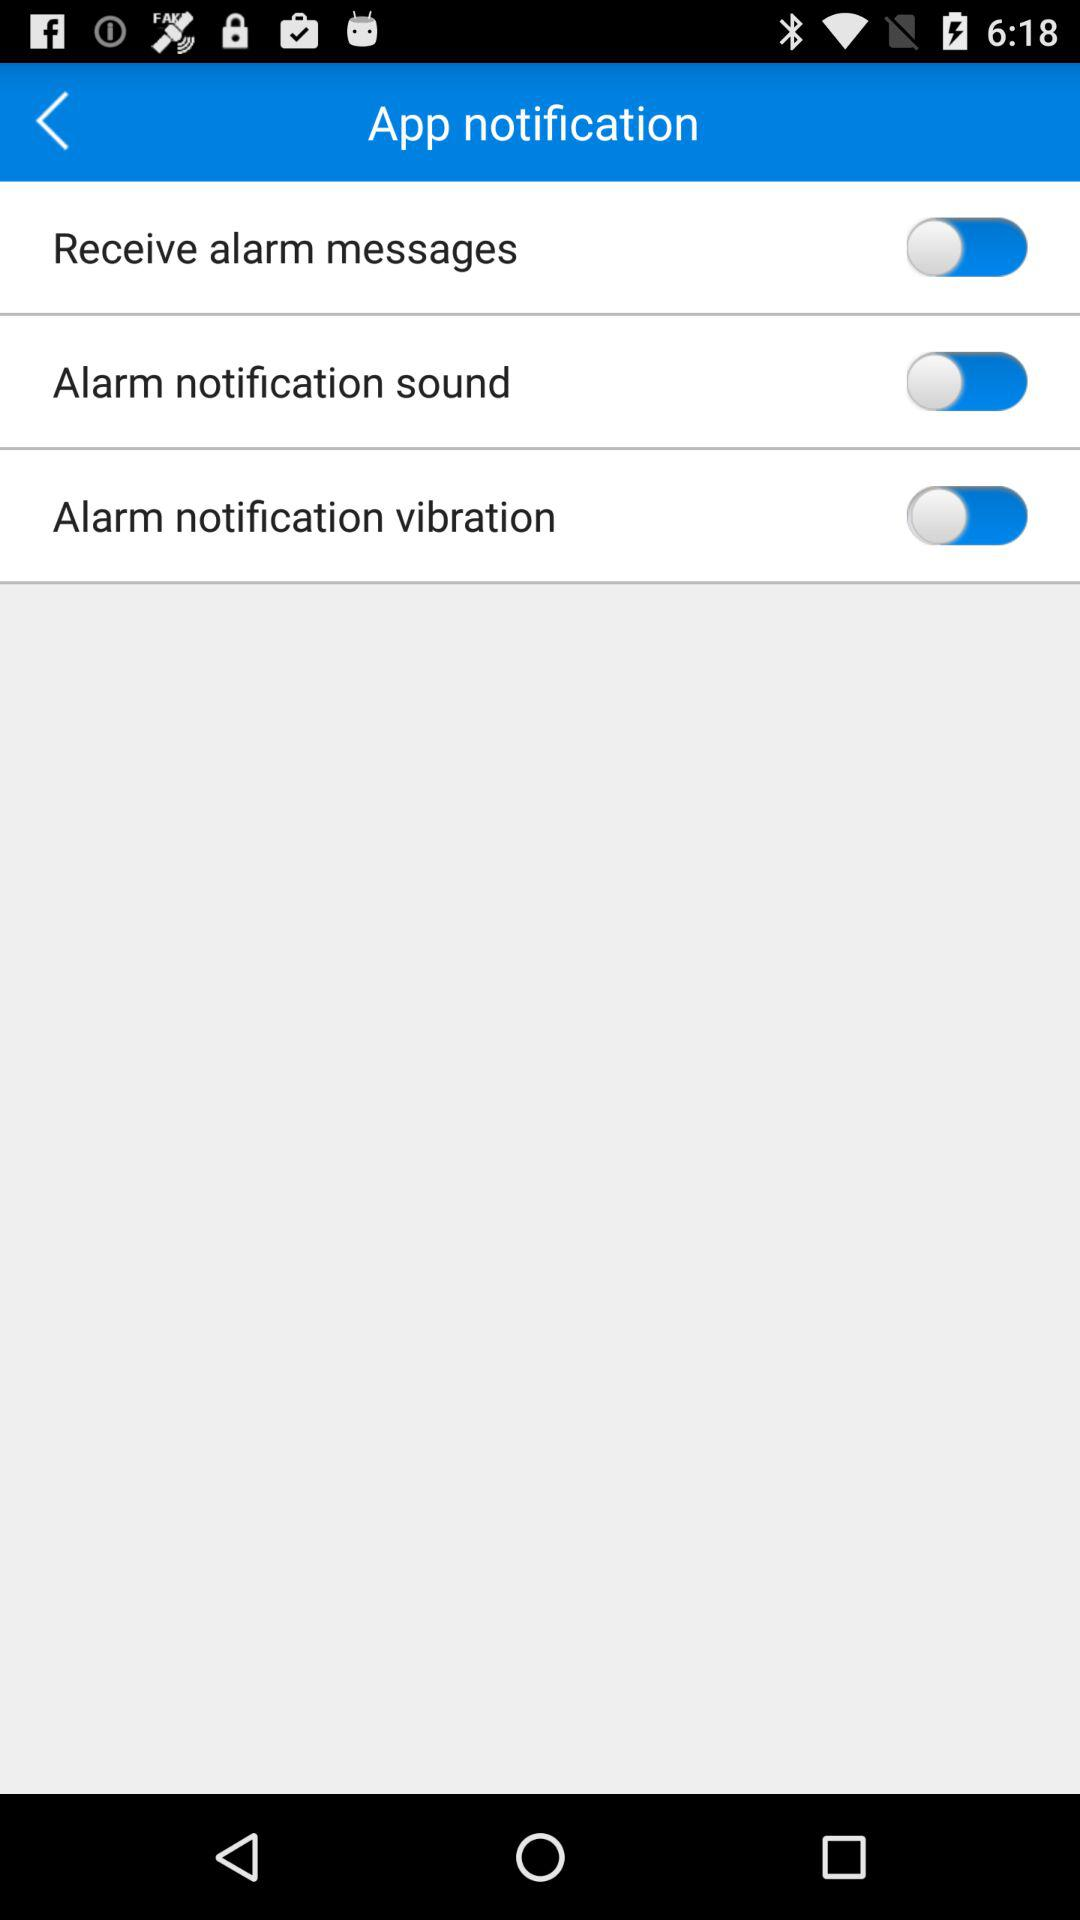How many switches are there for alarm notifications?
Answer the question using a single word or phrase. 3 